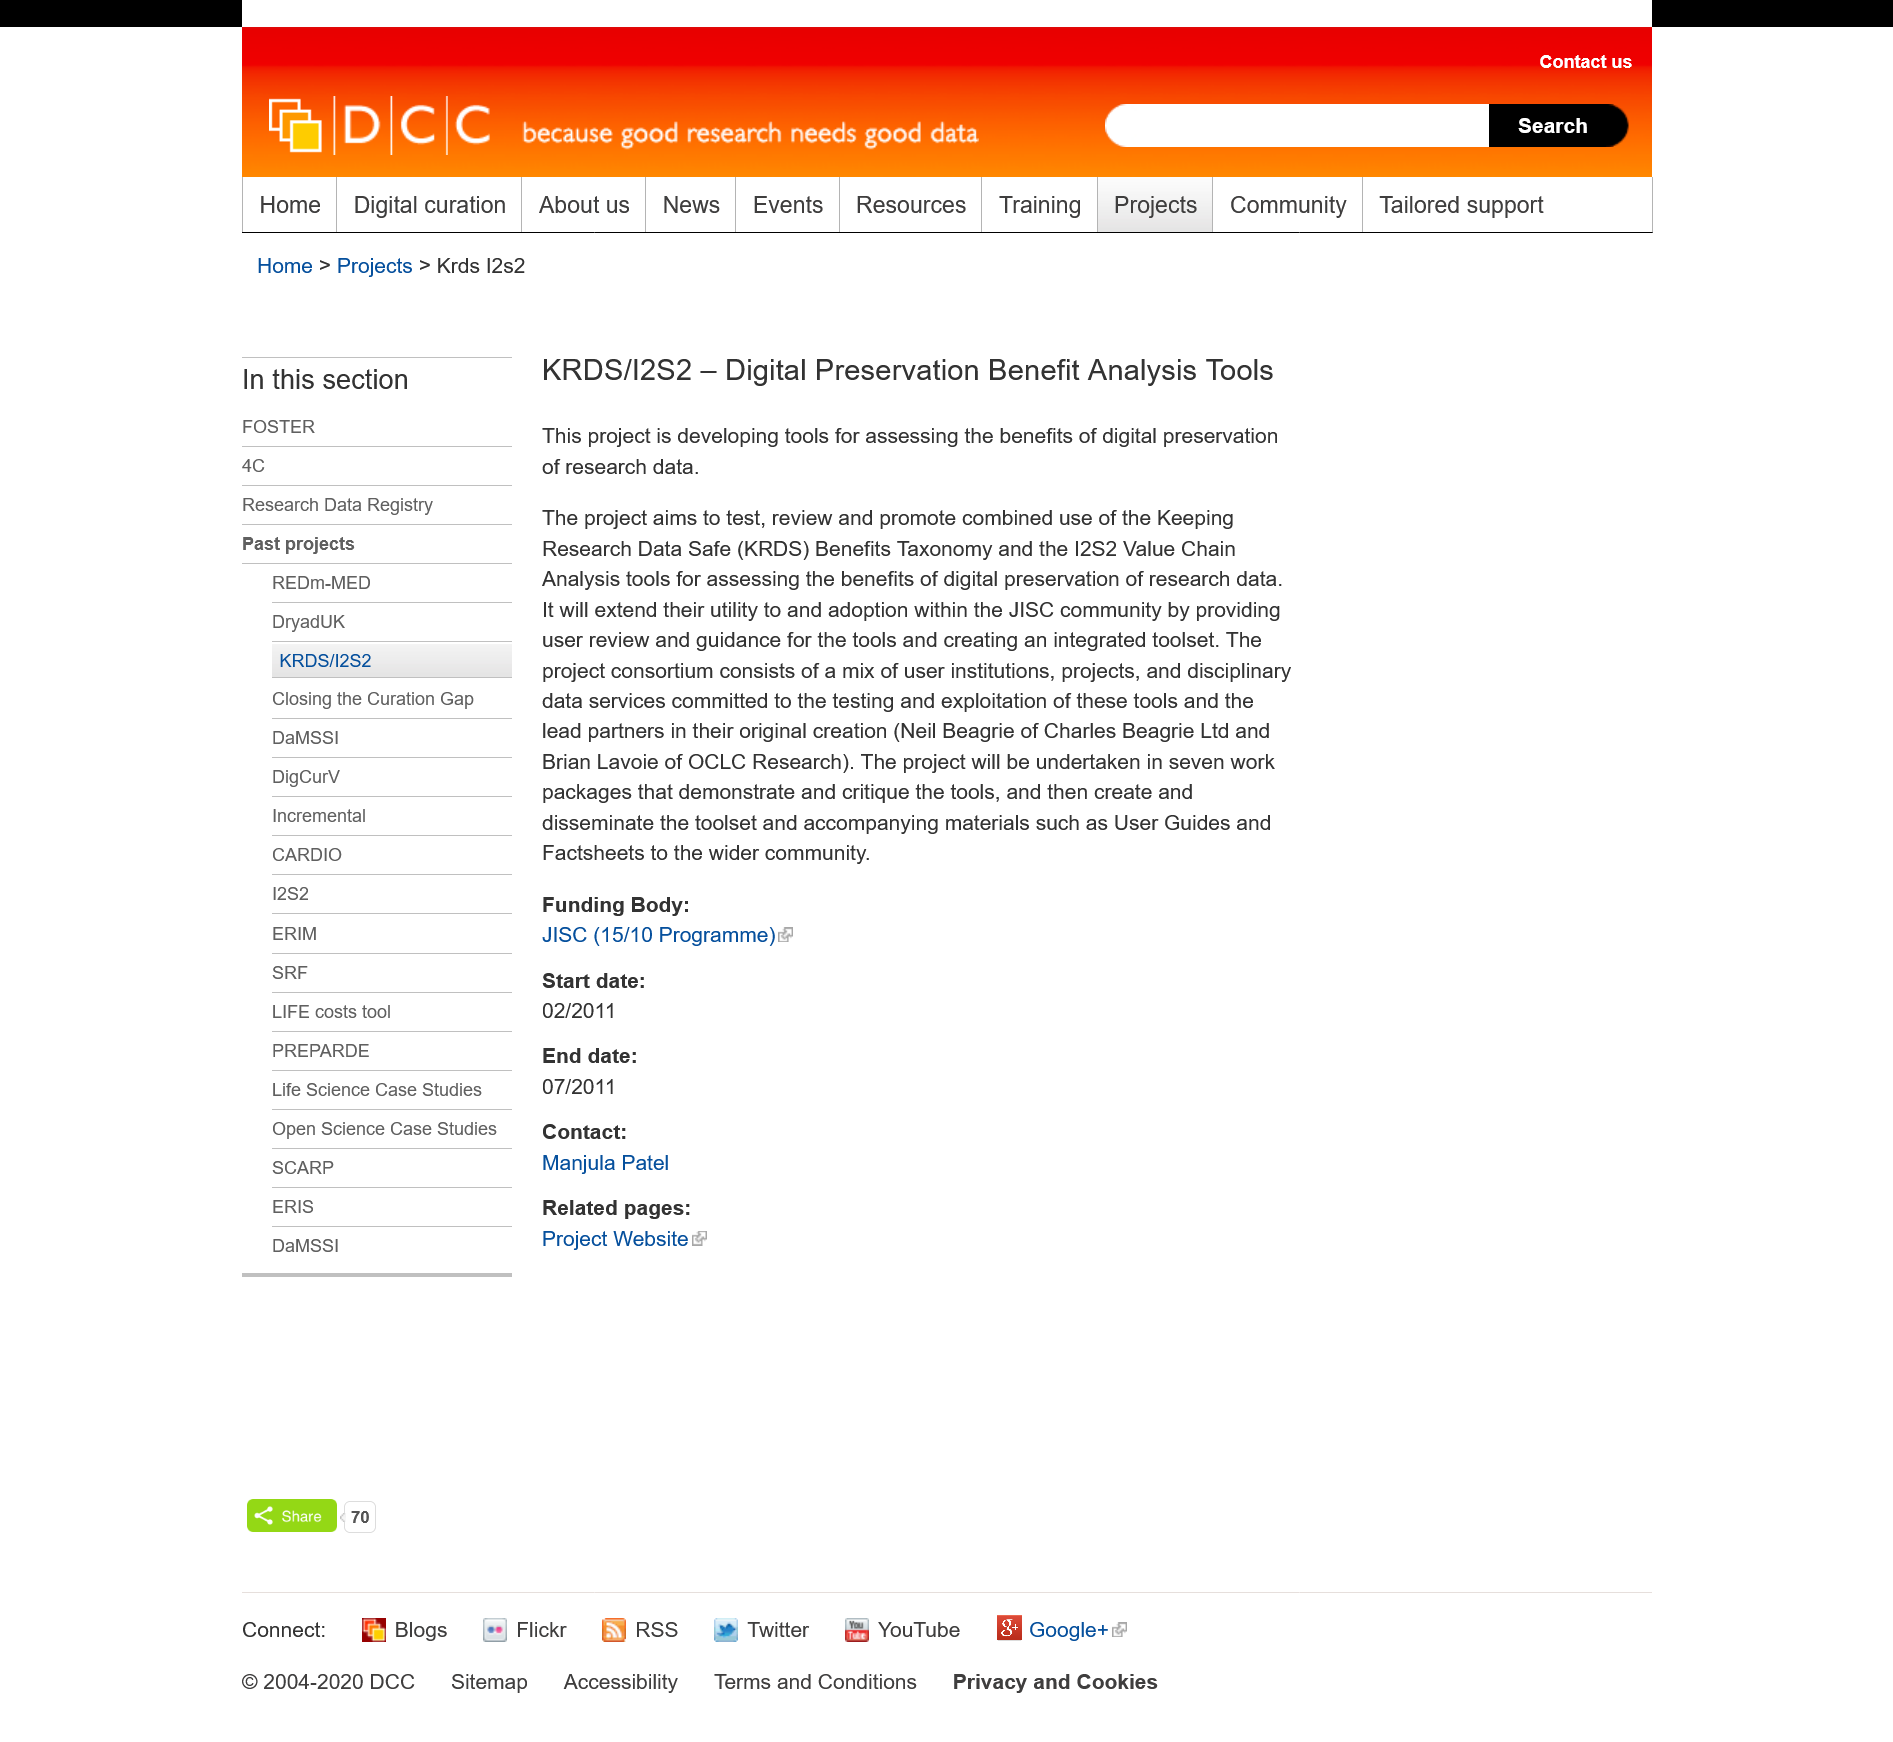Give some essential details in this illustration. The toolset will be accompanied by user guides and fact sheets for the wider community. The aim of the project is to develop tools for assessing the benefits of digital preservation of research data, with the goal of testing, reviewing, and promoting the combined use of keeping research data safe. The project will be completed using seven work packages. The number of work packages required to undertake this project is currently unknown. 